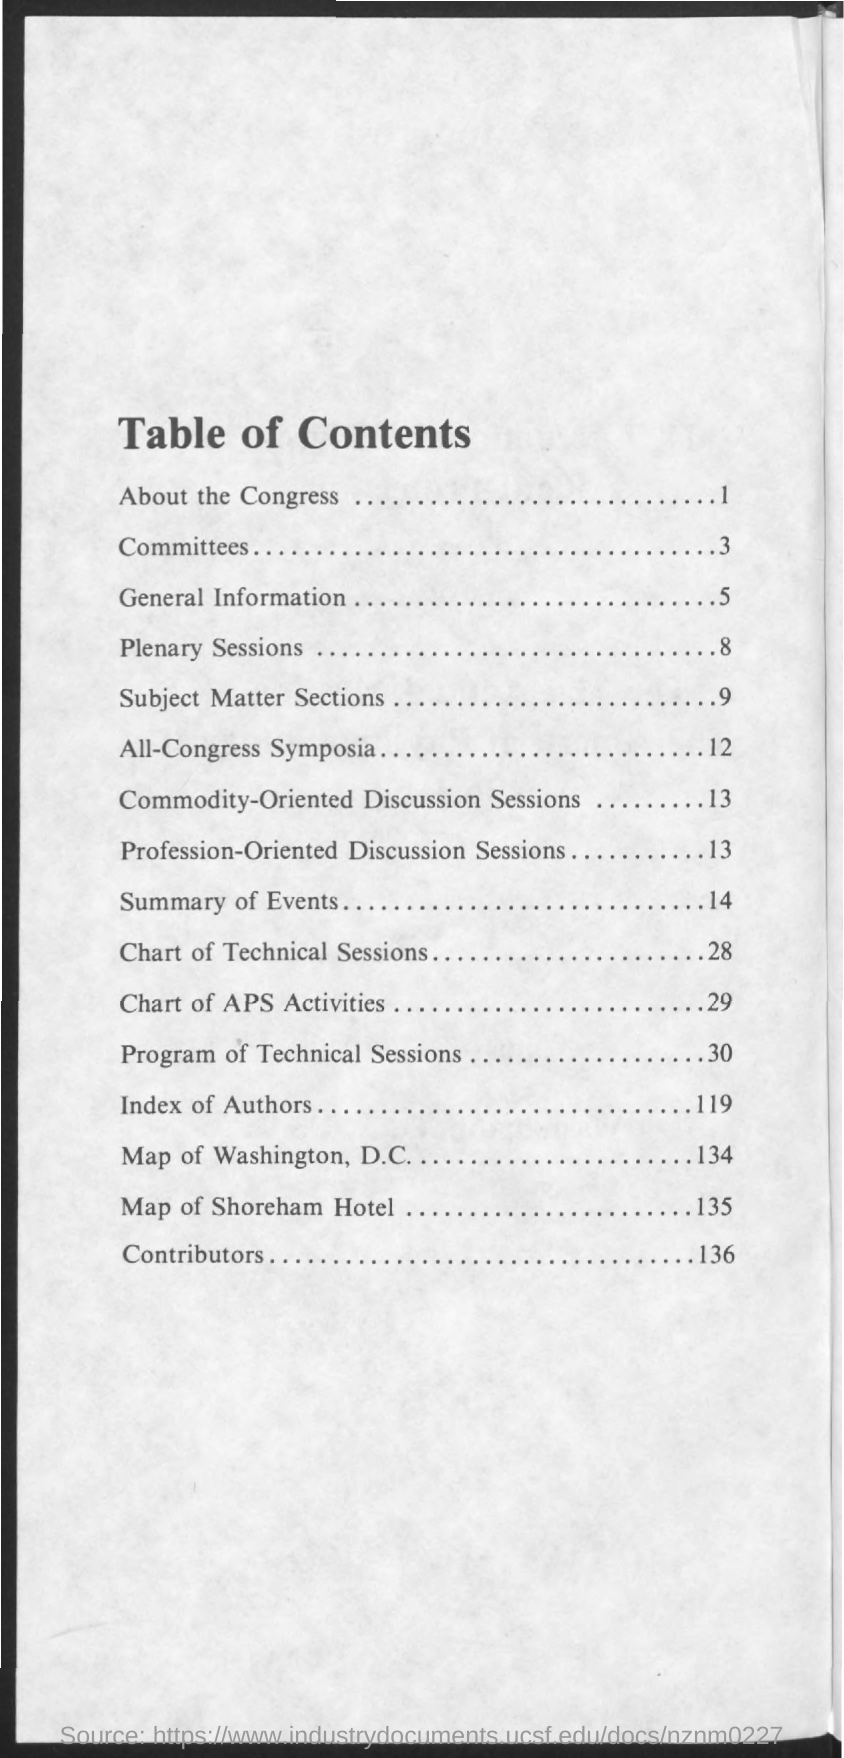List a handful of essential elements in this visual. The topic "Committees" is located on page 3. The topic of Plenary Sessions is located on page 8. The title of the document is Table of Contents. The topic that is on page number 119 is "Index of Authors. The topic 'Contributors' is located on page 136. 